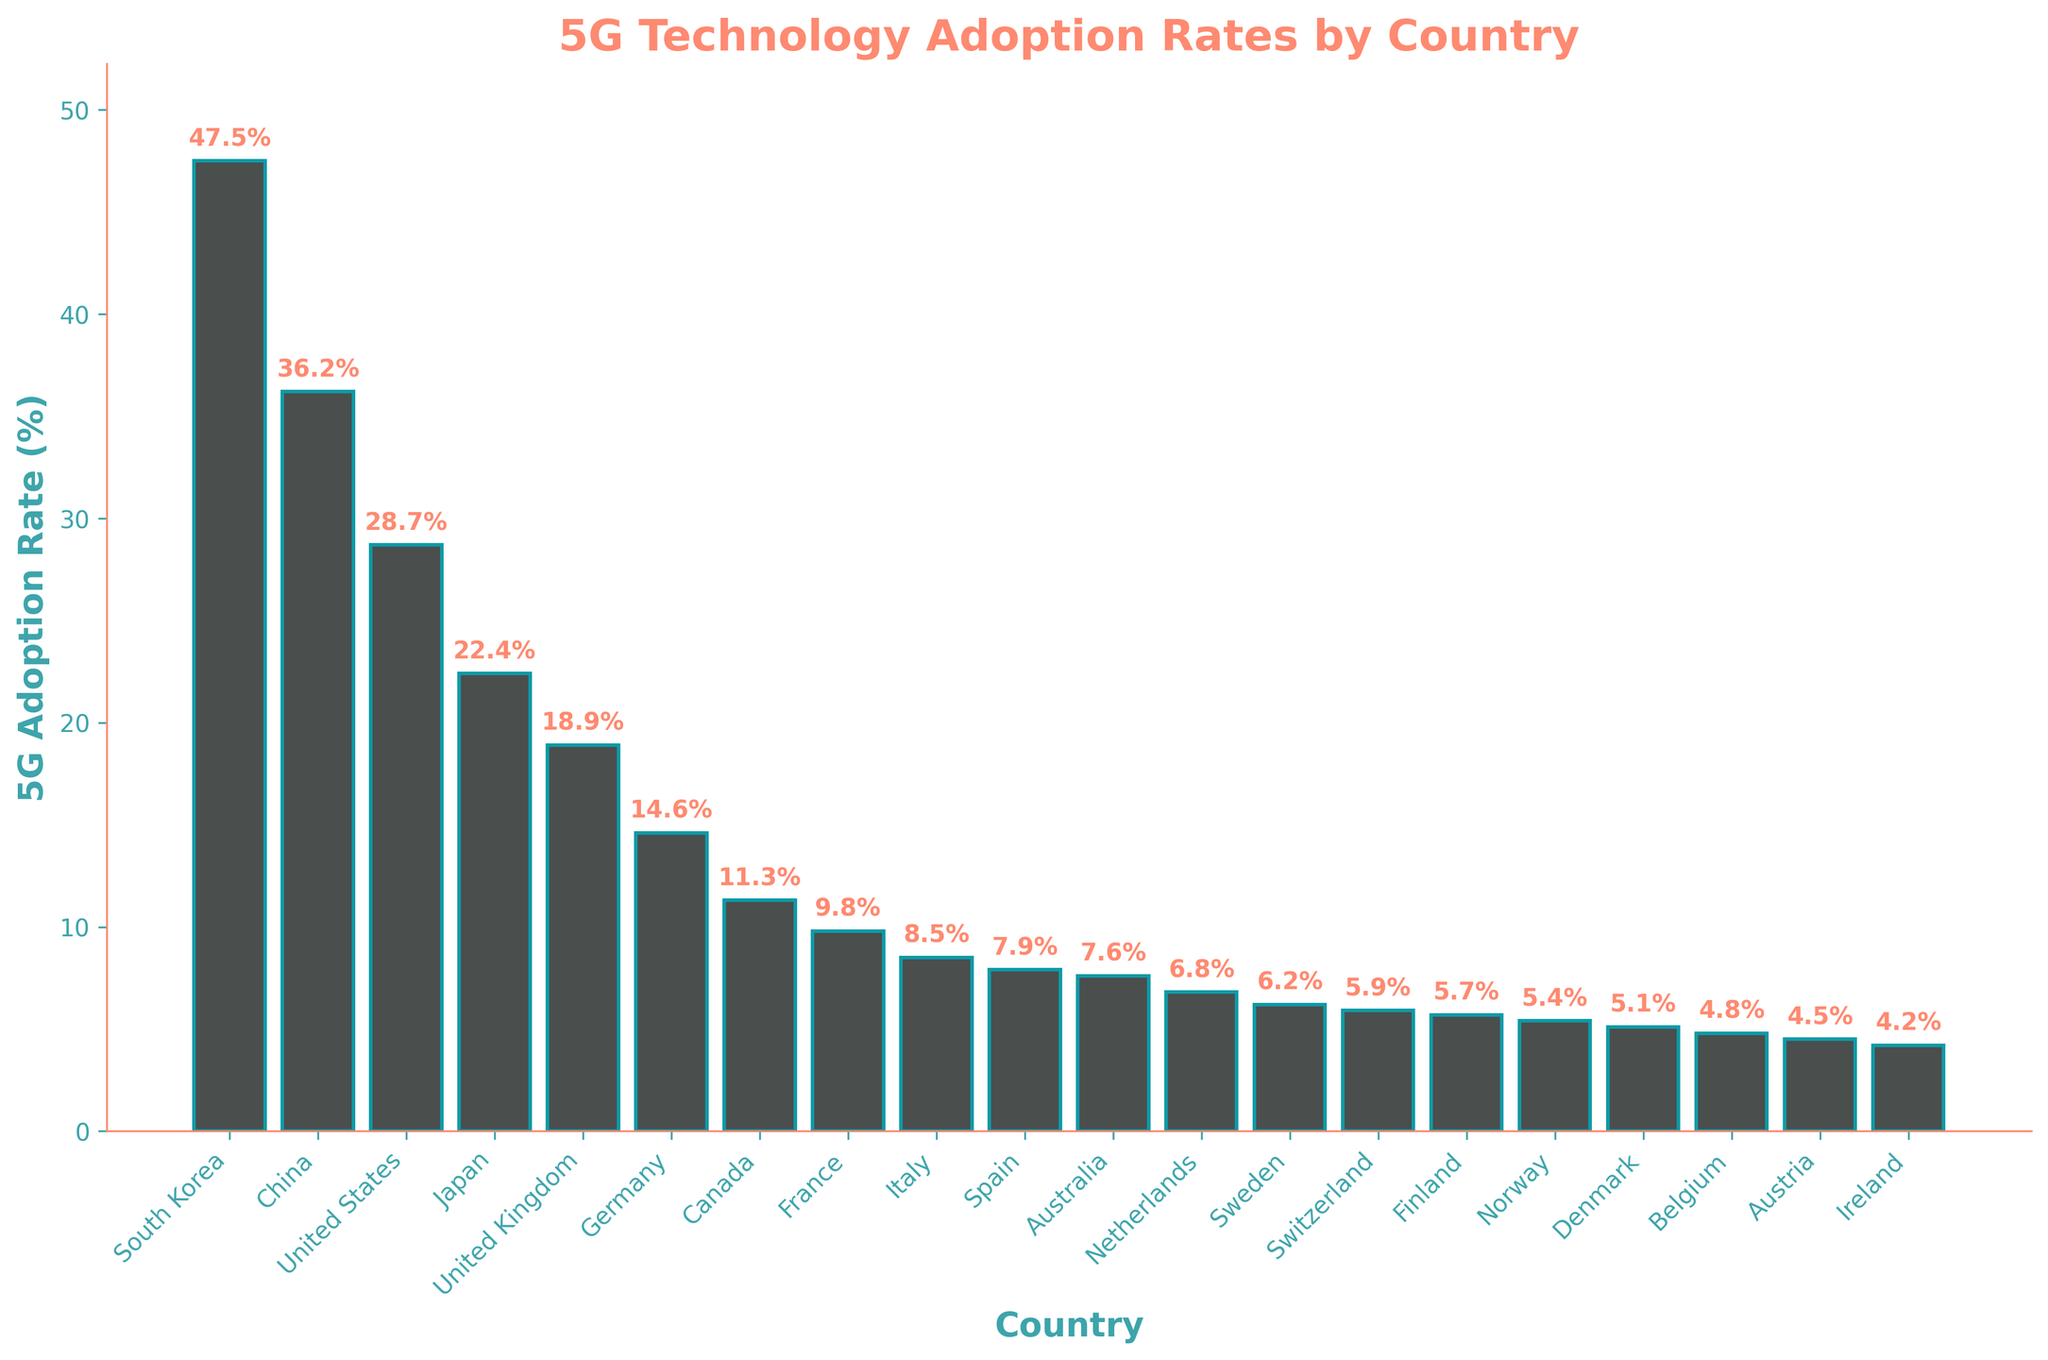Which country has the highest 5G adoption rate? South Korea has the highest bar on the chart, indicating the highest 5G adoption rate.
Answer: South Korea Which country has the lowest 5G adoption rate? Ireland has the lowest bar on the chart, indicating the lowest 5G adoption rate.
Answer: Ireland Compare the 5G adoption rate in the United States to that in China. Which country has a higher rate? The bar for China is higher than the bar for the United States, indicating China has a higher 5G adoption rate.
Answer: China What is the average 5G adoption rate for Germany, France and Italy? Add the adoption rates for Germany (14.6), France (9.8), and Italy (8.5) and divide by 3 to get the average: (14.6 + 9.8 + 8.5) / 3 = 32.9 / 3 = 10.97
Answer: 10.97 Is the 5G adoption rate in Japan greater than or less than the average adoption rate of all the countries shown? Sum the adoption rates of all countries and divide by the number of countries to find the average, then compare it to Japan's rate of 22.4. The total sum is 271.3 and the average is 271.3 / 21 ≈ 12.92. 22.4 is greater than 12.92.
Answer: Greater How many countries have a 5G adoption rate greater than 20%? By counting the bars higher than 20% from the chart: (South Korea, China, United States, and Japan) gives 4 countries.
Answer: 4 What is the difference in the 5G adoption rates between the United Kingdom and Germany? Subtract Germany's adoption rate (14.6) from the United Kingdom's (18.9): 18.9 - 14.6 = 4.3
Answer: 4.3 Between which two countries, adjacent in the ranking, is the largest difference in 5G adoption rates? By visually inspecting the differences between adjacent bars, the largest difference is between South Korea (47.5%) and China (36.2%): 47.5 - 36.2 = 11.3.
Answer: South Korea and China How much higher is South Korea’s 5G adoption rate compared to the average of Belgium, Austria, and Ireland? Calculate the average of Belgium (4.8), Austria (4.5), and Ireland (4.2): (4.8 + 4.5 + 4.2) / 3 = 4.5. Then, subtract this average from South Korea's rate: 47.5 - 4.5 = 43.
Answer: 43 Which three countries have the closest 5G adoption rates and what are their values? By inspecting the bars, Norway (5.4), Denmark (5.1), and Belgium (4.8) have close adoption rates.
Answer: Norway (5.4), Denmark (5.1), Belgium (4.8) 